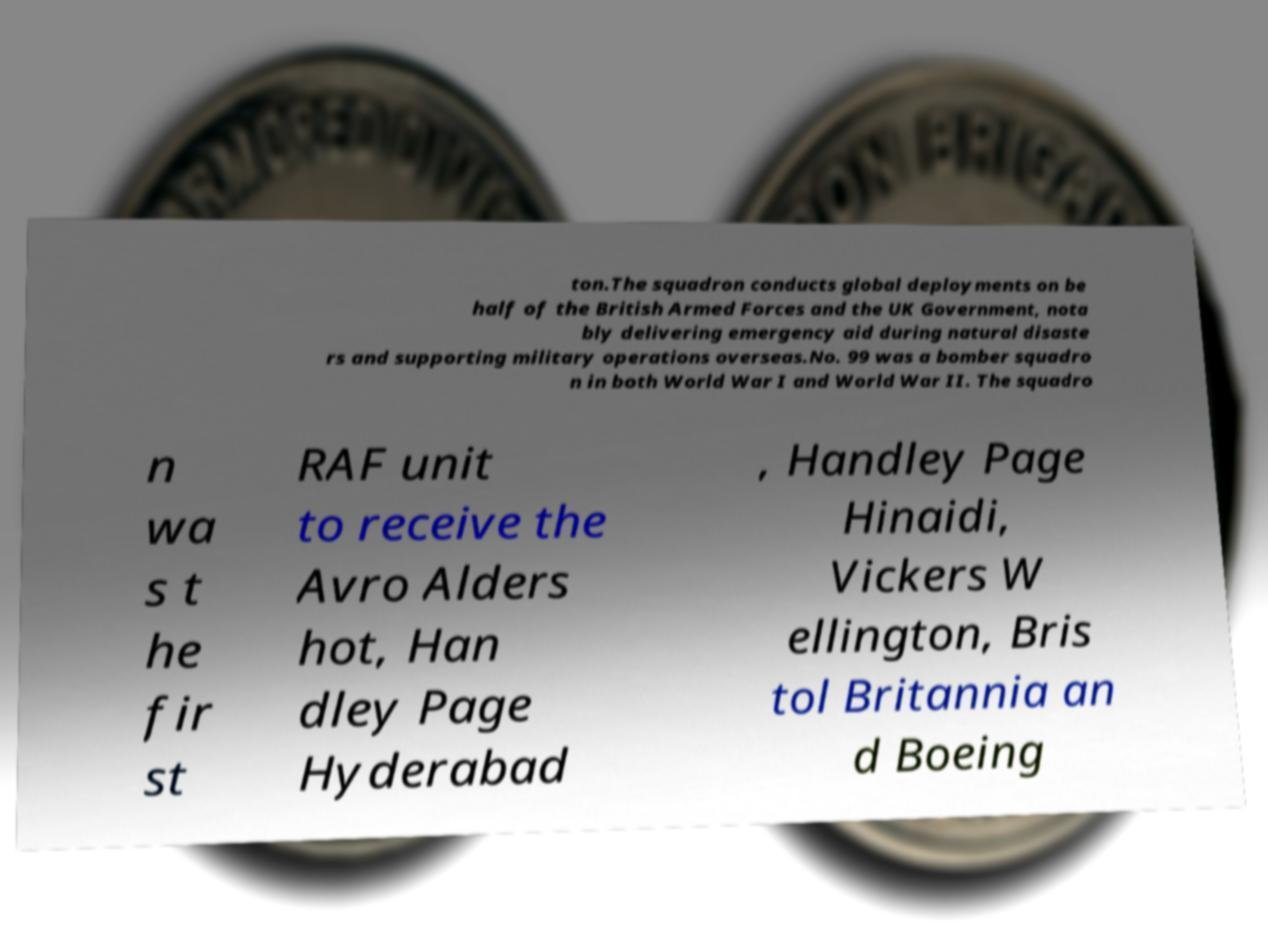For documentation purposes, I need the text within this image transcribed. Could you provide that? ton.The squadron conducts global deployments on be half of the British Armed Forces and the UK Government, nota bly delivering emergency aid during natural disaste rs and supporting military operations overseas.No. 99 was a bomber squadro n in both World War I and World War II. The squadro n wa s t he fir st RAF unit to receive the Avro Alders hot, Han dley Page Hyderabad , Handley Page Hinaidi, Vickers W ellington, Bris tol Britannia an d Boeing 